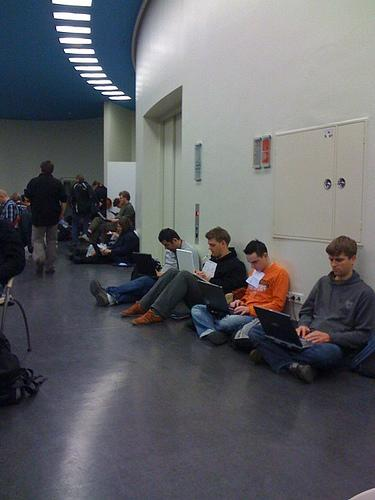What are the men against the wall working on? laptops 